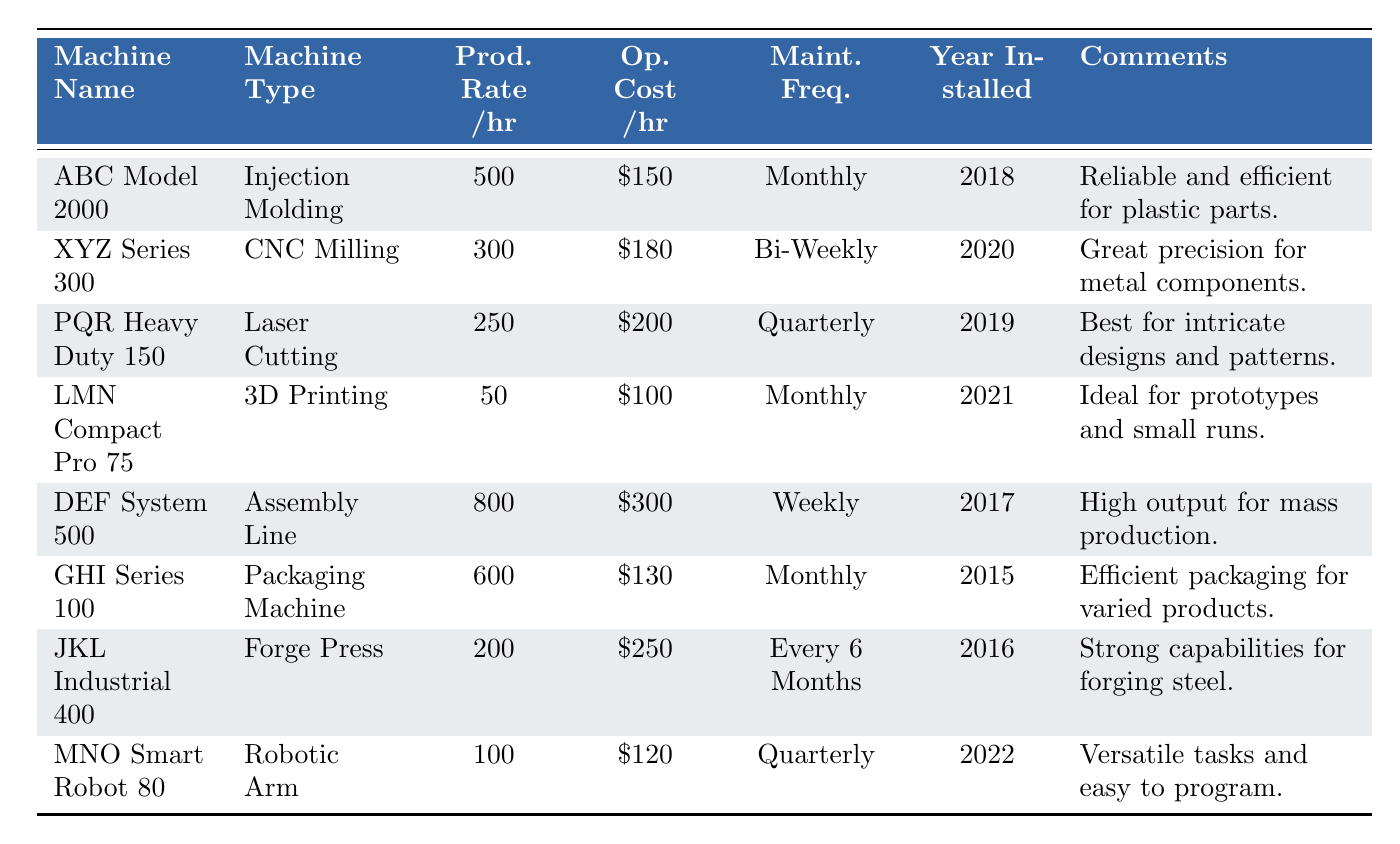What is the highest production rate per hour in the table? The highest production rate can be found by comparing all production rates listed. DEF System 500 has the highest production rate at 800 pieces per hour.
Answer: 800 Which machine has the lowest operational cost per hour? By looking at the operational costs listed in the table, LMN Compact Pro 75 has the lowest cost at 100 dollars per hour.
Answer: 100 Is the XYZ Series 300 installed before the PQR Heavy Duty 150? The year installed for XYZ Series 300 is 2020, which is after the year installed for PQR Heavy Duty 150, which is 2019. Therefore, it is false that XYZ Series 300 was installed before PQR Heavy Duty 150.
Answer: No How much is the difference in operational costs between the DEF System 500 and GHI Series 100? The operational cost of DEF System 500 is 300 dollars per hour and GHI Series 100 is 130 dollars per hour. The difference is calculated as 300 - 130 = 170 dollars.
Answer: 170 On average, how many units can all machines produce per hour? First, we sum the production rates: 500 + 300 + 250 + 50 + 800 + 600 + 200 + 100 = 2850. There are 8 machines, so the average production rate is 2850 / 8 = 356.25 units per hour.
Answer: 356.25 